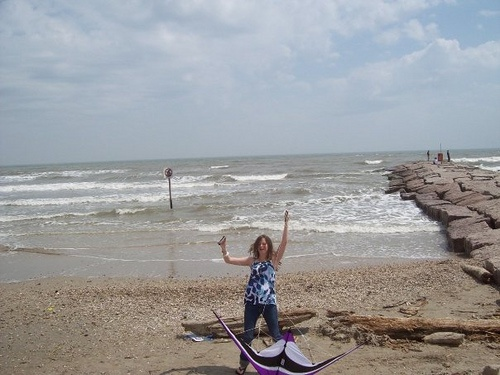Describe the objects in this image and their specific colors. I can see people in darkgray, black, gray, and navy tones, kite in darkgray, black, and gray tones, and people in darkgray, black, and gray tones in this image. 